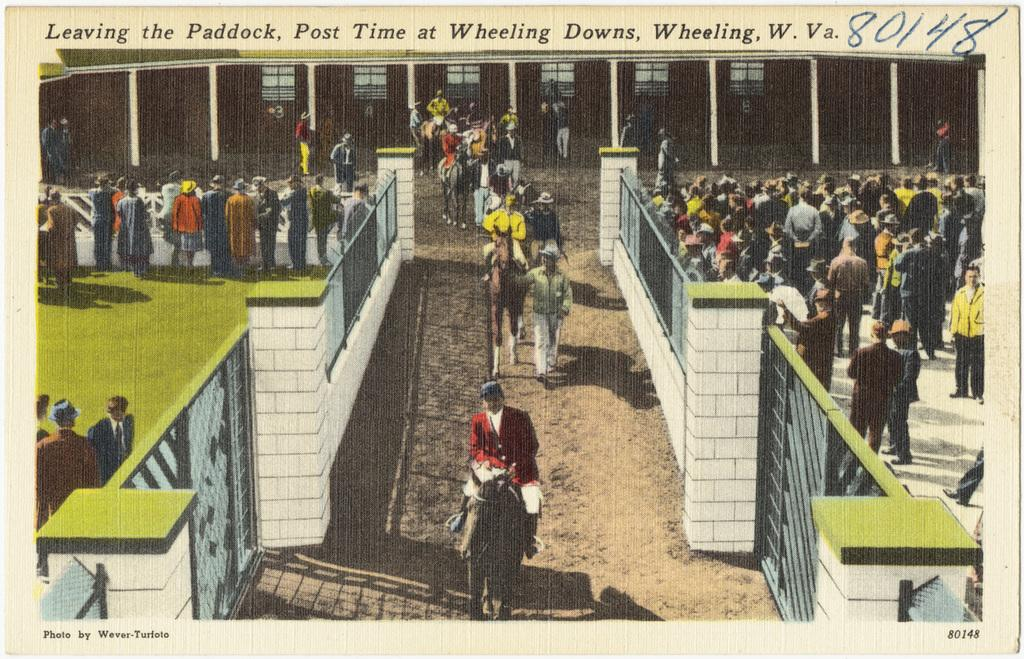<image>
Render a clear and concise summary of the photo. A postcard says leaving the Paddock in Wheeling. 